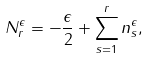Convert formula to latex. <formula><loc_0><loc_0><loc_500><loc_500>N _ { r } ^ { \epsilon } = - \frac { \epsilon } { 2 } + \sum _ { s = 1 } ^ { r } n _ { s } ^ { \epsilon } ,</formula> 